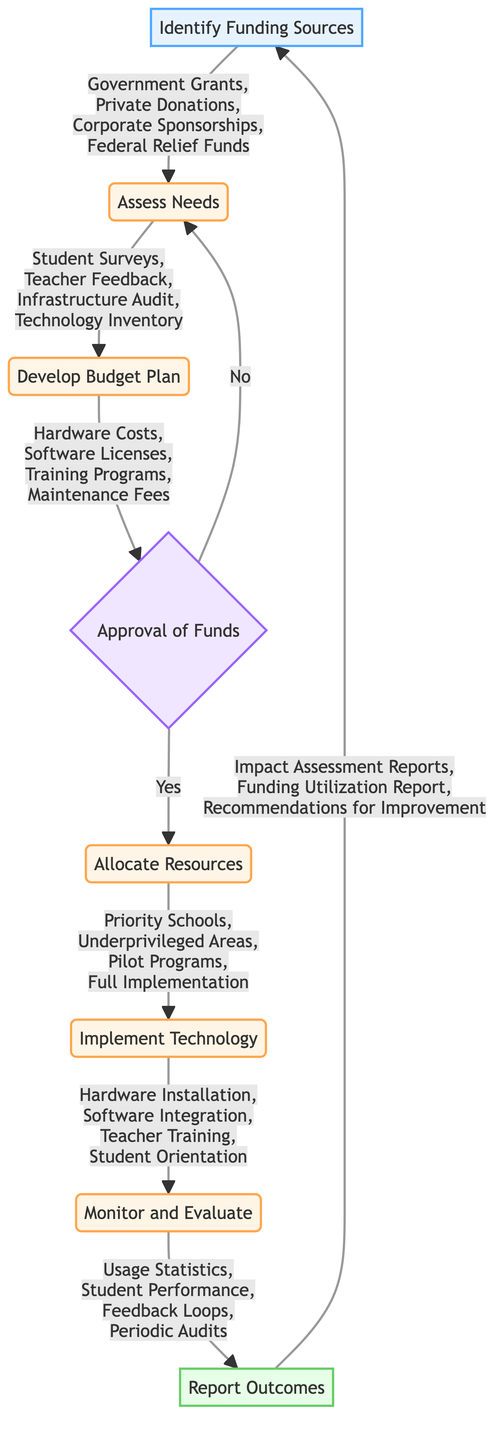What are the funding sources identified in the first step? The first step lists four funding sources: Government Grants, Private Donations, Corporate Sponsorships, and Federal Relief Funds.
Answer: Government Grants, Private Donations, Corporate Sponsorships, Federal Relief Funds What activities are included in the needs assessment? The needs assessment includes four activities: Student Surveys, Teacher Feedback, Infrastructure Audit, and Technology Inventory.
Answer: Student Surveys, Teacher Feedback, Infrastructure Audit, Technology Inventory What are the components of the budget plan? The budget plan has four components: Hardware Costs, Software Licenses, Training Programs, and Maintenance Fees.
Answer: Hardware Costs, Software Licenses, Training Programs, Maintenance Fees What happens if the funds are not approved? If the funds are not approved, the process loops back to the Assess Needs step.
Answer: Back to Assess Needs How many types of resources are allocated in the resource allocation step? There are four types of resources mentioned for allocation: Priority Schools, Underprivileged Areas, Pilot Programs, and Full Implementation.
Answer: Four What phases are included in the implementation of technology? The implementation of technology includes four phases: Hardware Installation, Software Integration, Teacher Training, and Student Orientation.
Answer: Hardware Installation, Software Integration, Teacher Training, Student Orientation What metrics are monitored and evaluated post-implementation? The metrics monitored and evaluated include: Usage Statistics, Student Performance, Feedback Loops, and Periodic Audits.
Answer: Usage Statistics, Student Performance, Feedback Loops, Periodic Audits What does the final output include in terms of reports? The final output includes three types of reports: Impact Assessment Reports, Funding Utilization Report, and Recommendations for Improvement.
Answer: Impact Assessment Reports, Funding Utilization Report, Recommendations for Improvement Which decision criteria are used to approve funds? The criteria used to approve funds include: Cost-Benefit Analysis, Resource Prioritization, and Stakeholder Consultation.
Answer: Cost-Benefit Analysis, Resource Prioritization, Stakeholder Consultation 